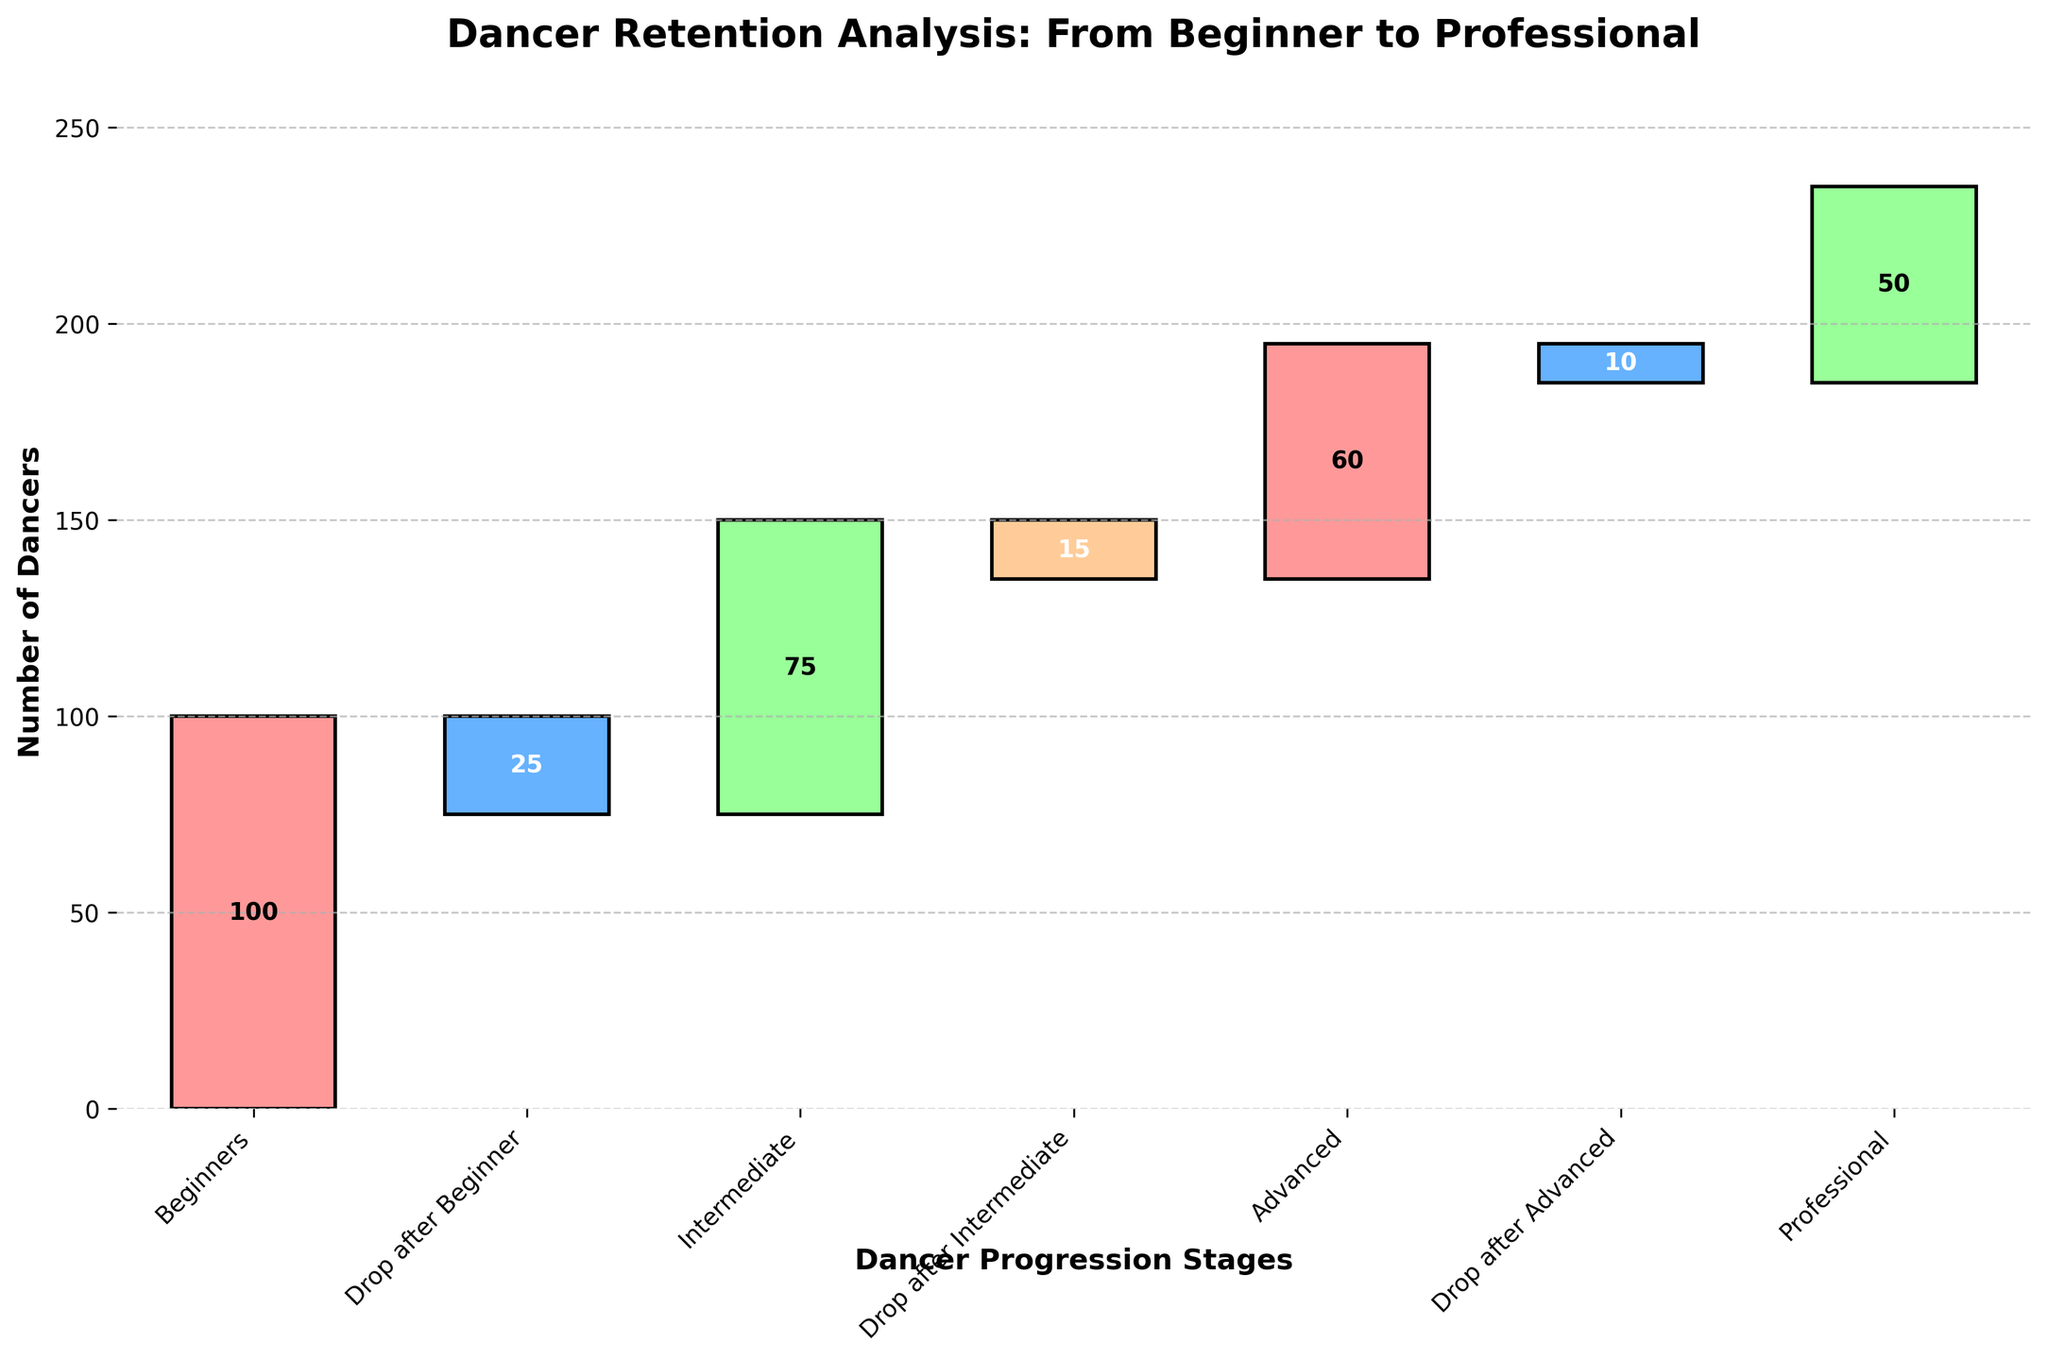What is the title of the waterfall chart? The title is located at the top of the figure and provides an overview of what the chart is depicting.
Answer: Dancer Retention Analysis: From Beginner to Professional How many levels are represented in the chart? Count the number of unique dancer levels labeled on the x-axis.
Answer: 6 What are the initial number of beginners? Look at the first bar labeled "Beginners" to determine the number of dancers.
Answer: 100 How many dancers drop out after the beginner level? Find the bar labeled "Drop after Beginner" and note the value it represents.
Answer: 25 What is the number of dancers at the advanced level? Check the bar labeled "Advanced" to see the number of dancers.
Answer: 60 How many dancers transition from intermediate to advanced level? Calculate the difference between the numbers at intermediate and advanced levels, accounting for any drop-offs. (75 - 15 = 60)
Answer: 60 By how much does the number of dancers decrease from beginner to intermediate levels? Calculate the difference between the number of dancers at the beginner and intermediate levels. (100 - 75 = 25)
Answer: 25 How many dancers remain at the professional level compared to the advanced level? Subtract the number of dancers at the professional level from those at the advanced level. (60 - 50 = 10)
Answer: 10 Which level experiences the highest drop-off rate? Compare the bars representing drop-offs after each level to determine the highest value.
Answer: Drop after Beginner What is the cumulative number of drop-offs? Add up all the drop-off values: 25 (Beginner) + 15 (Intermediate) + 10 (Advanced) = 50
Answer: 50 